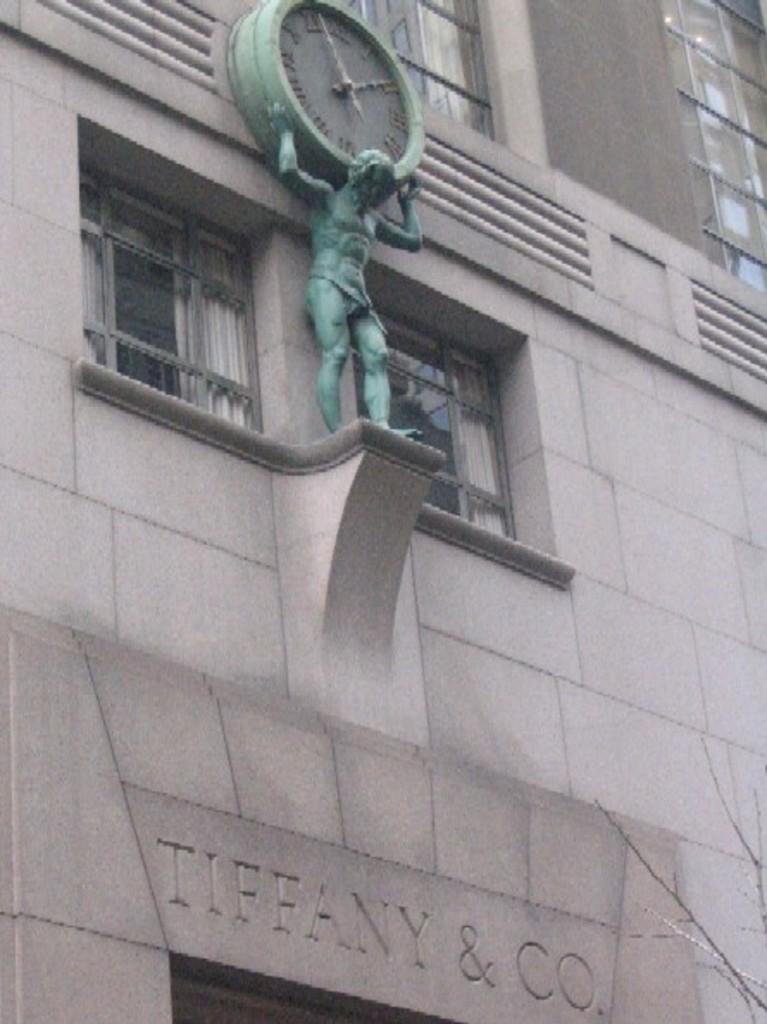What type of structure is visible in the image? There is a building in the image. What is on the building? There is a sculpture on the building. What does the sculpture depict? The sculpture depicts a man holding a clock. What type of carriage can be seen passing by the building in the image? There is no carriage visible in the image; it only shows a building with a sculpture on it. 